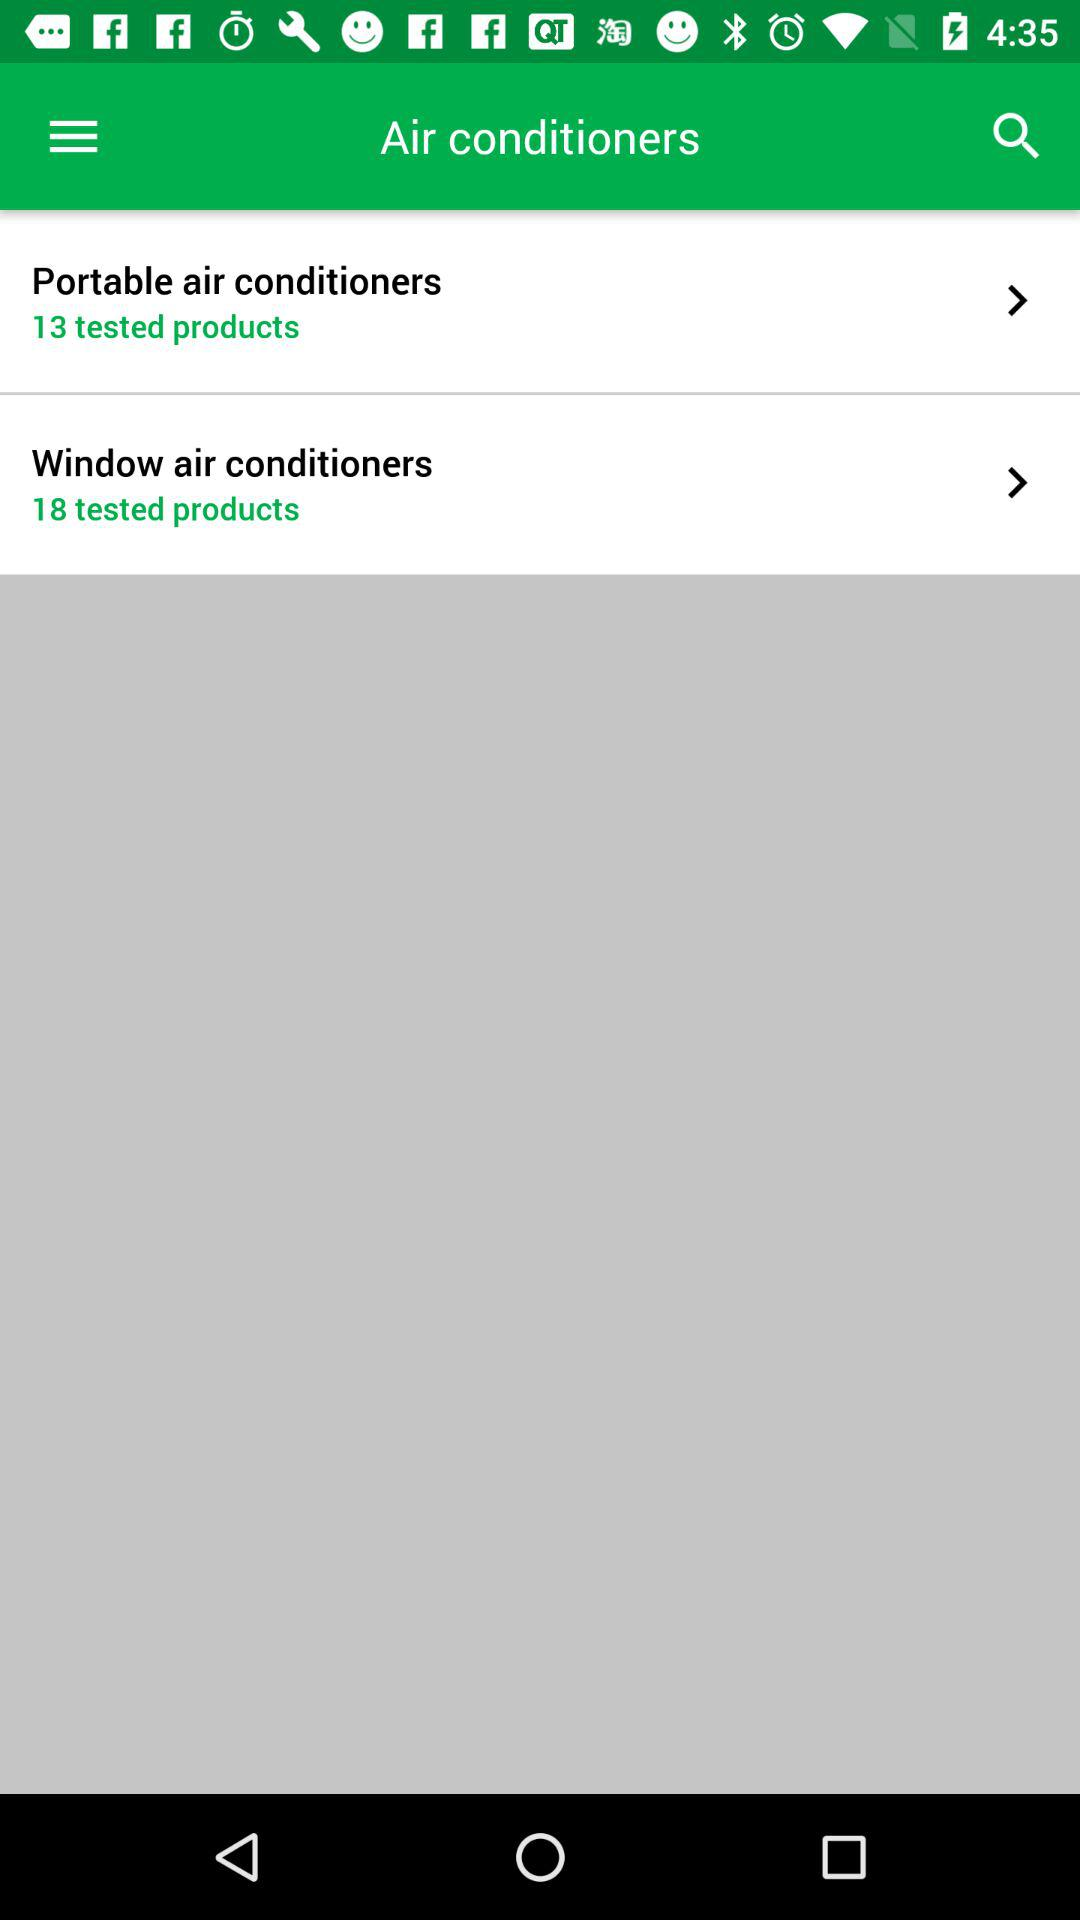Which brands were tested?
When the provided information is insufficient, respond with <no answer>. <no answer> 